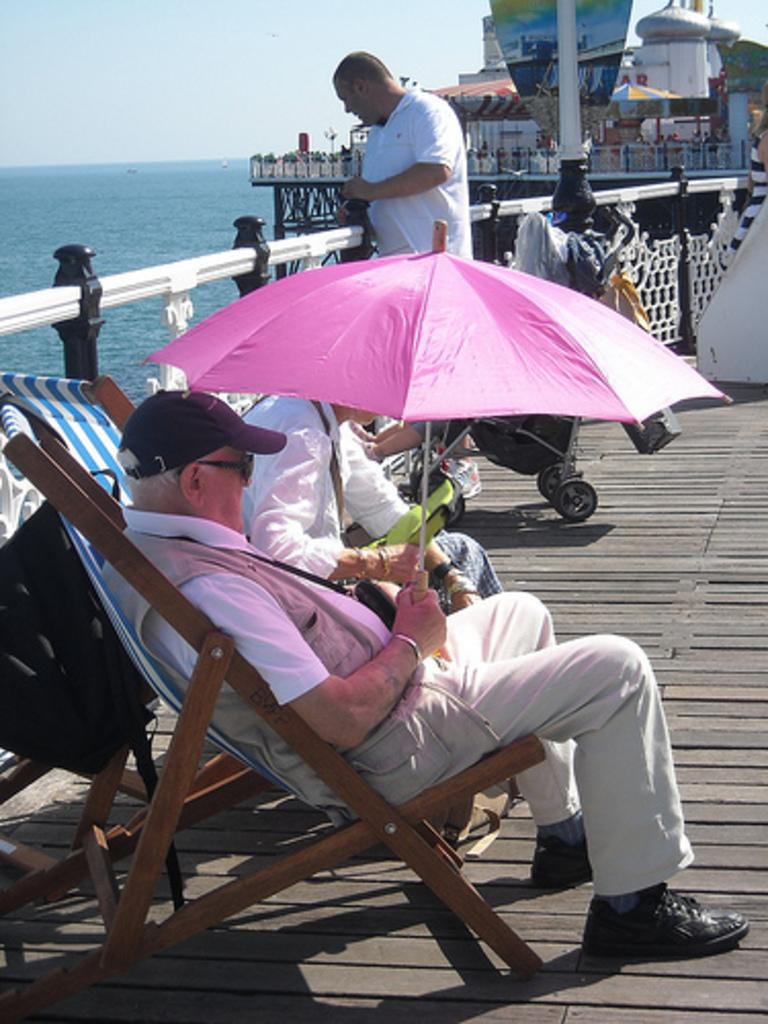Who or what can be seen in the image? There are people in the image. What objects are present that people might sit on? There are chairs in the image. What type of structure is visible in the image? There is a house in the image. What type of barrier can be seen in the image? There is a fence in the image. What object is present for providing shade? There is an umbrella in the image. What natural element is visible in the image? There is water visible in the image. What part of the environment is visible in the image? The sky is visible in the image. What statement can be made about the existence of a bucket in the image? There is no bucket present in the image. What type of creature is shown interacting with the umbrella in the image? There is no creature shown interacting with the umbrella in the image; only people, chairs, a house, a fence, water, and the sky are present. 